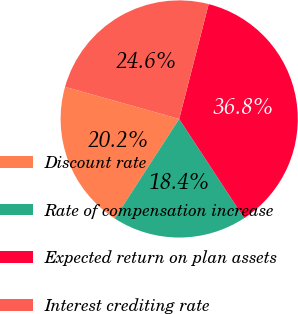Convert chart. <chart><loc_0><loc_0><loc_500><loc_500><pie_chart><fcel>Discount rate<fcel>Rate of compensation increase<fcel>Expected return on plan assets<fcel>Interest crediting rate<nl><fcel>20.22%<fcel>18.38%<fcel>36.76%<fcel>24.63%<nl></chart> 